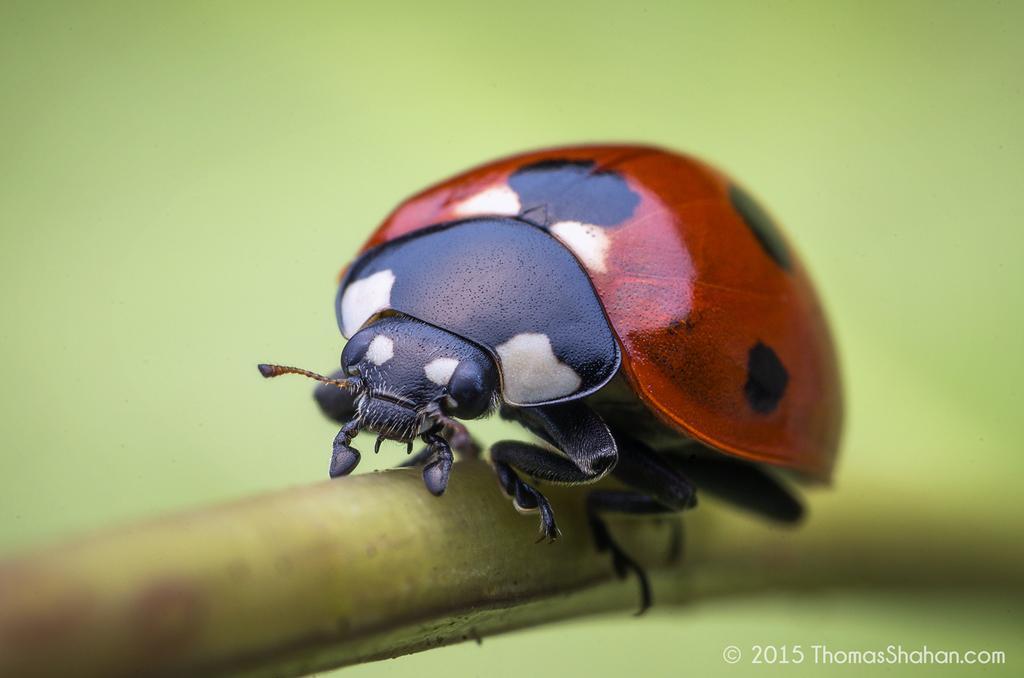Please provide a concise description of this image. In this image, we can see an insect on an object. We can also see the blurred background. We can see some text on the bottom right corner. 